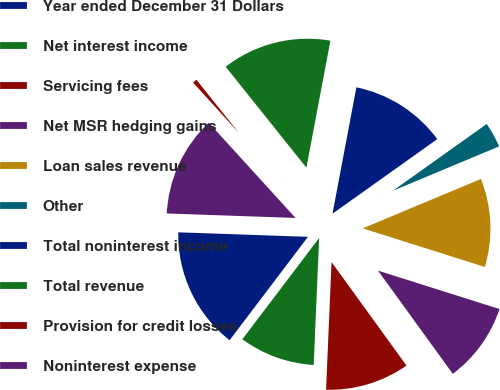<chart> <loc_0><loc_0><loc_500><loc_500><pie_chart><fcel>Year ended December 31 Dollars<fcel>Net interest income<fcel>Servicing fees<fcel>Net MSR hedging gains<fcel>Loan sales revenue<fcel>Other<fcel>Total noninterest income<fcel>Total revenue<fcel>Provision for credit losses<fcel>Noninterest expense<nl><fcel>15.23%<fcel>9.64%<fcel>10.66%<fcel>10.15%<fcel>11.17%<fcel>3.55%<fcel>12.18%<fcel>13.71%<fcel>1.02%<fcel>12.69%<nl></chart> 